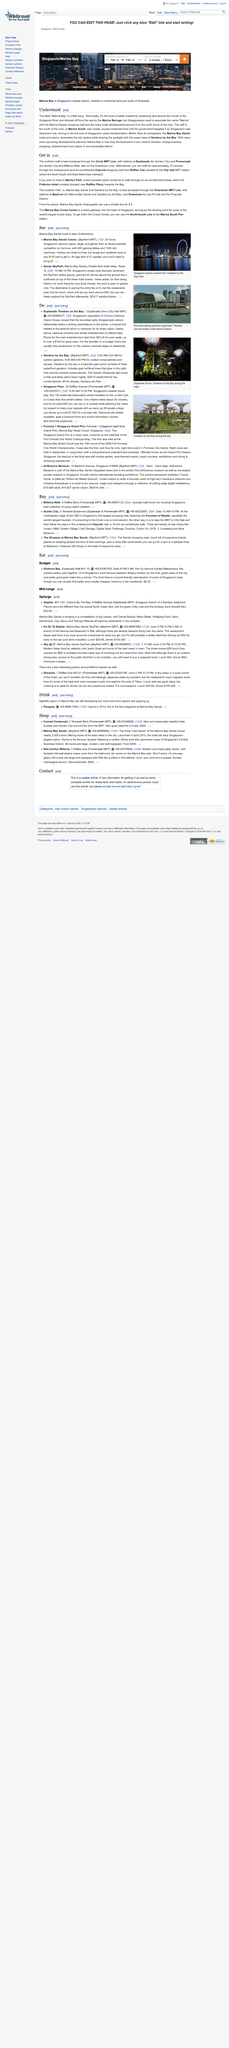Outline some significant characteristics in this image. I, Marina Bay, am located in the country of Singapore, specifically in the southern region, adjacent to the river. Marina Bay is Singapore's newest district. The Marina Bay skyline is dominated by the imposing structure of the Marina Bay Sands hotel and casino, which stands tall and imposing, along with the breathtaking super trees of Gardens by the Bay. 